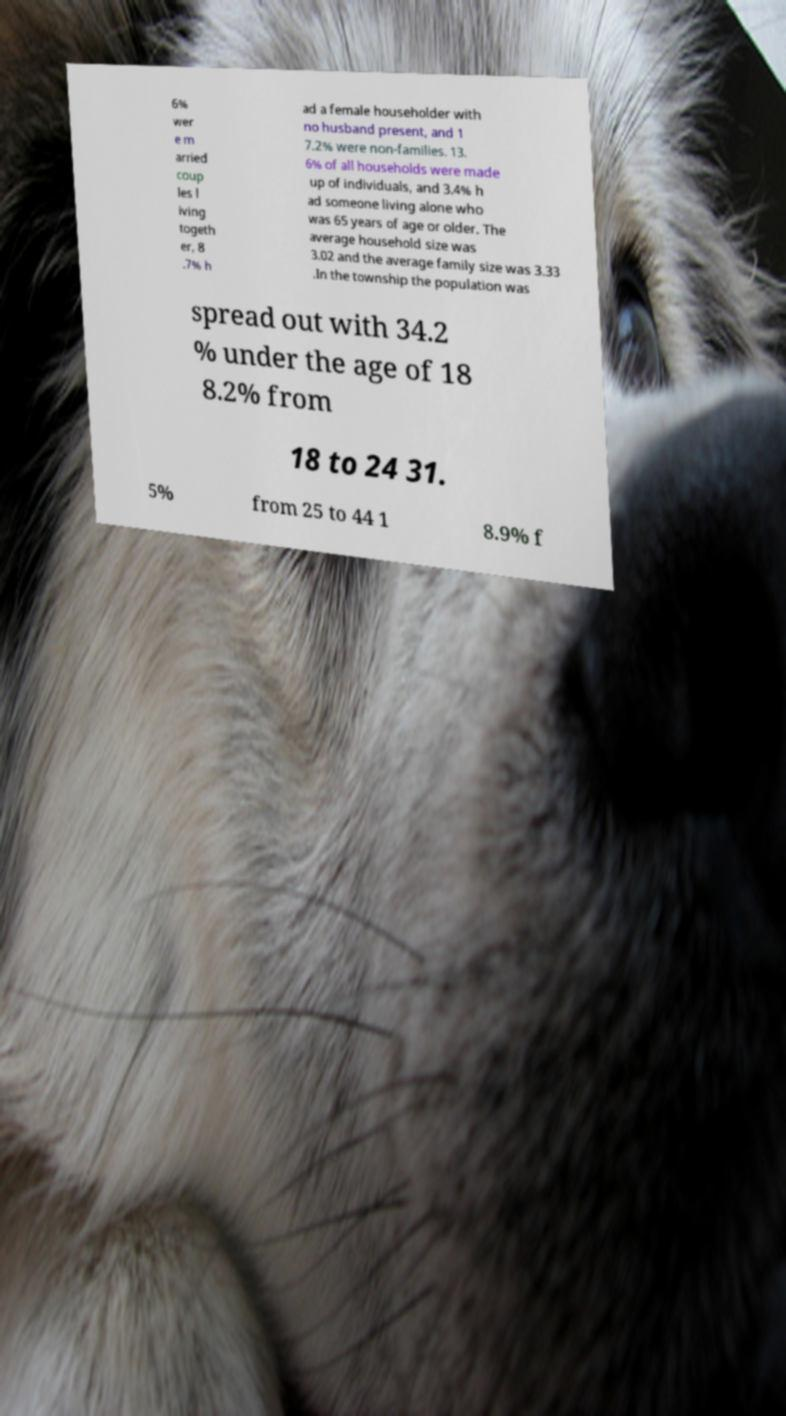Please identify and transcribe the text found in this image. 6% wer e m arried coup les l iving togeth er, 8 .7% h ad a female householder with no husband present, and 1 7.2% were non-families. 13. 6% of all households were made up of individuals, and 3.4% h ad someone living alone who was 65 years of age or older. The average household size was 3.02 and the average family size was 3.33 .In the township the population was spread out with 34.2 % under the age of 18 8.2% from 18 to 24 31. 5% from 25 to 44 1 8.9% f 